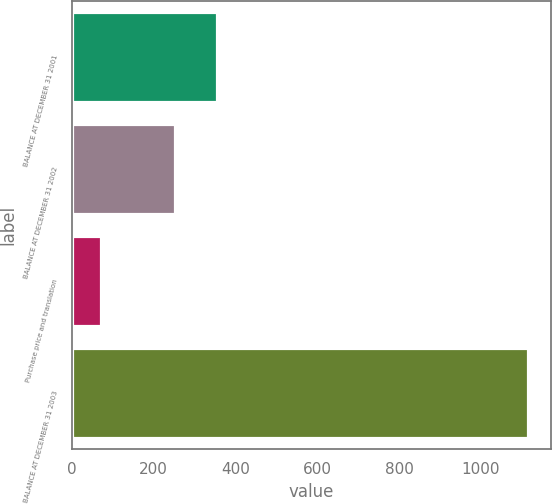Convert chart to OTSL. <chart><loc_0><loc_0><loc_500><loc_500><bar_chart><fcel>BALANCE AT DECEMBER 31 2001<fcel>BALANCE AT DECEMBER 31 2002<fcel>Purchase price and translation<fcel>BALANCE AT DECEMBER 31 2003<nl><fcel>356.4<fcel>252<fcel>71<fcel>1115<nl></chart> 